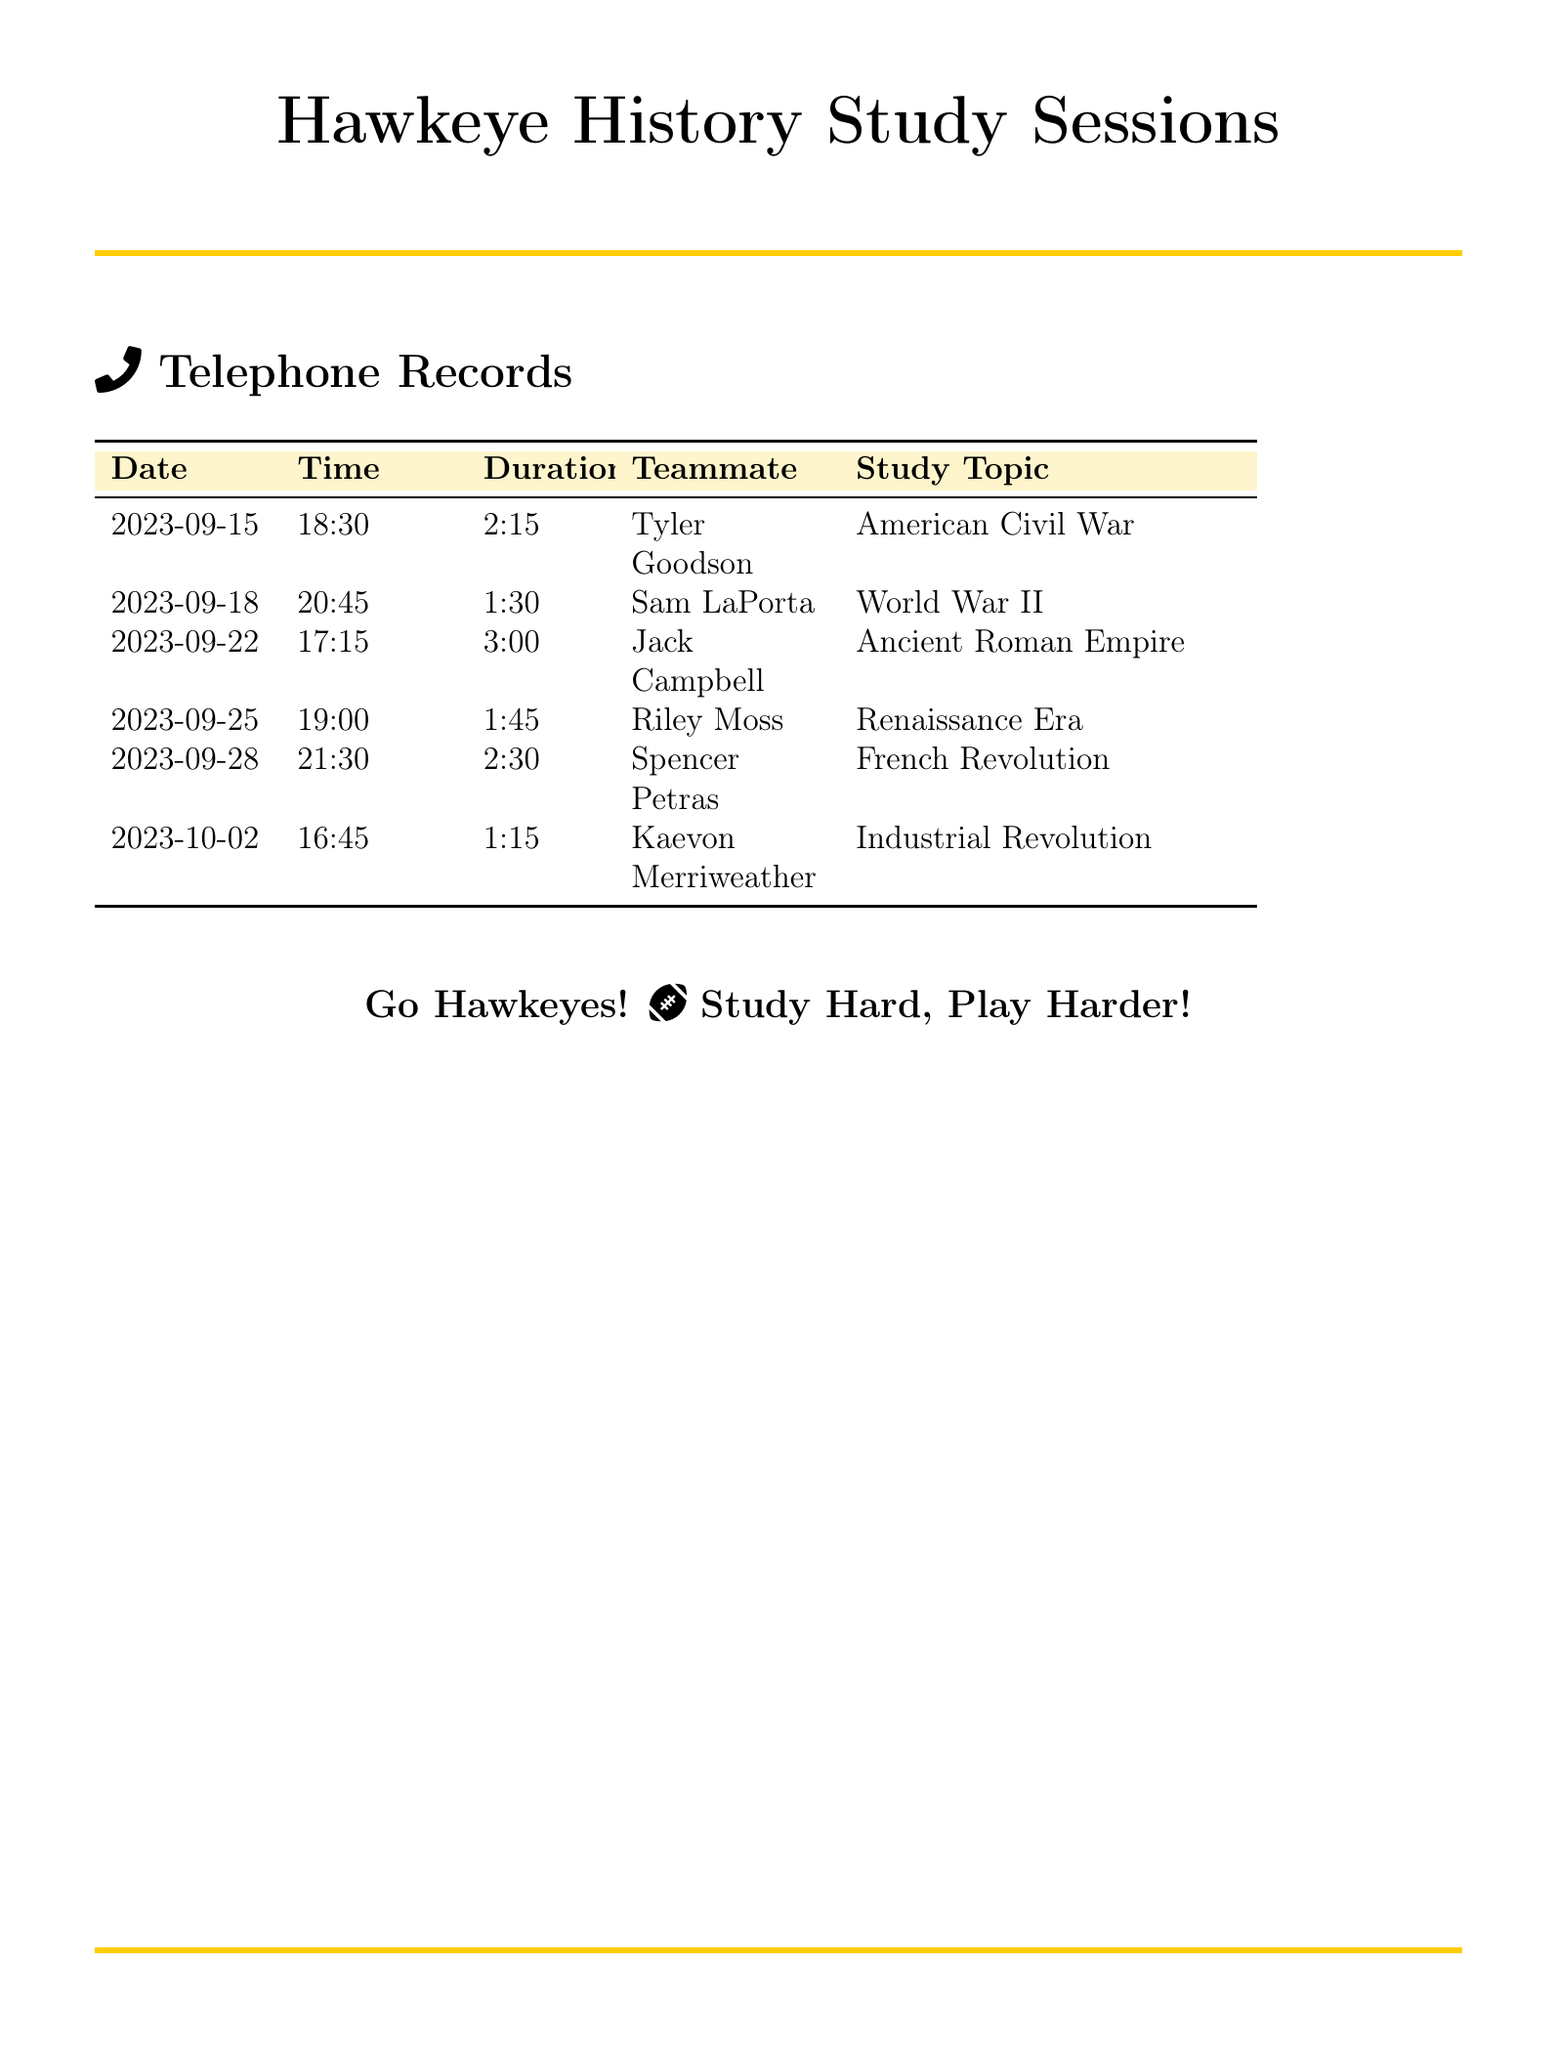What date did you call Tyler Goodson? The document lists the call to Tyler Goodson on the date of September 15, 2023.
Answer: September 15, 2023 How long was the call with Sam LaPorta? Sam LaPorta's call duration is specified as 1 hour and 30 minutes.
Answer: 1:30 What was the study topic discussed on September 22? The study topic on September 22 was the Ancient Roman Empire.
Answer: Ancient Roman Empire Who called regarding the Renaissance Era? The call regarding the Renaissance Era was made to Riley Moss.
Answer: Riley Moss Which teammate did you talk to about World War II? The document shows the call about World War II was with Sam LaPorta.
Answer: Sam LaPorta What was the longest call duration in the records? The longest call recorded was 3 hours, which was with Jack Campbell.
Answer: 3:00 How many total calls are listed in the document? There are 6 calls listed in the telephone records.
Answer: 6 What time was the call with Spencer Petras? The time for the call with Spencer Petras was 21:30.
Answer: 21:30 On which date did you study the Industrial Revolution? The Industrial Revolution was studied on October 2, 2023.
Answer: October 2, 2023 